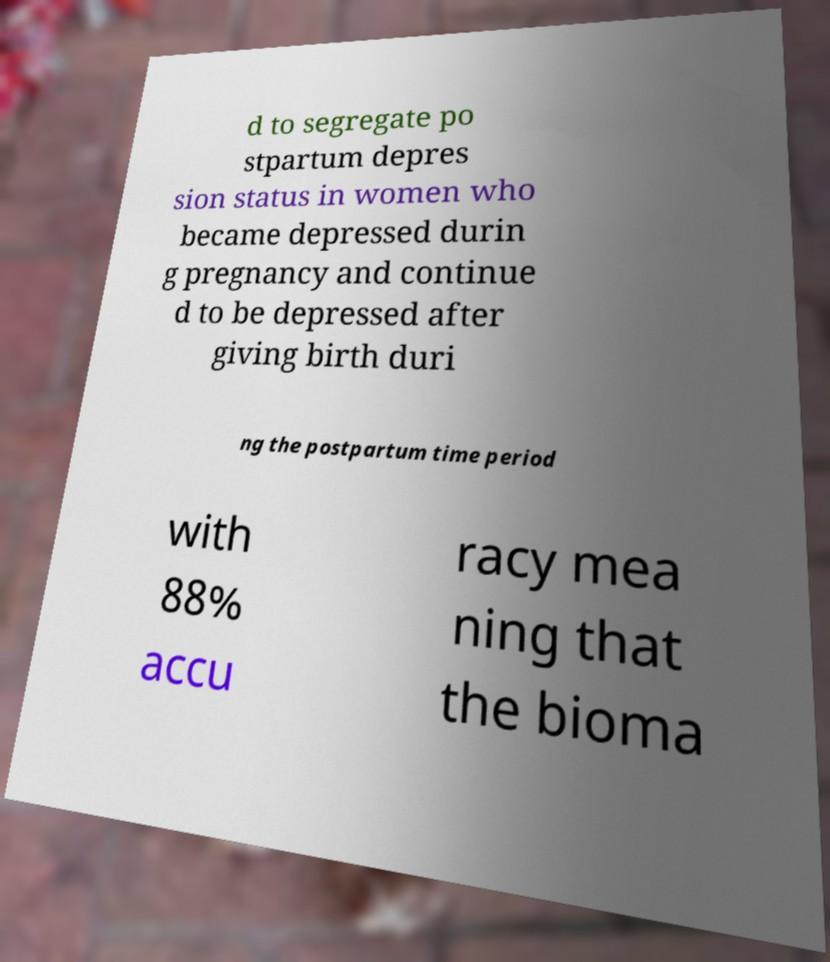Please identify and transcribe the text found in this image. d to segregate po stpartum depres sion status in women who became depressed durin g pregnancy and continue d to be depressed after giving birth duri ng the postpartum time period with 88% accu racy mea ning that the bioma 